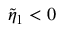Convert formula to latex. <formula><loc_0><loc_0><loc_500><loc_500>\tilde { \eta } _ { 1 } < 0</formula> 